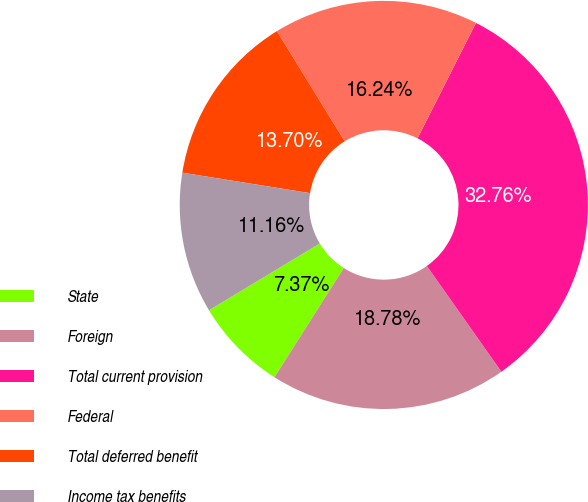Convert chart. <chart><loc_0><loc_0><loc_500><loc_500><pie_chart><fcel>State<fcel>Foreign<fcel>Total current provision<fcel>Federal<fcel>Total deferred benefit<fcel>Income tax benefits<nl><fcel>7.37%<fcel>18.78%<fcel>32.77%<fcel>16.24%<fcel>13.7%<fcel>11.16%<nl></chart> 